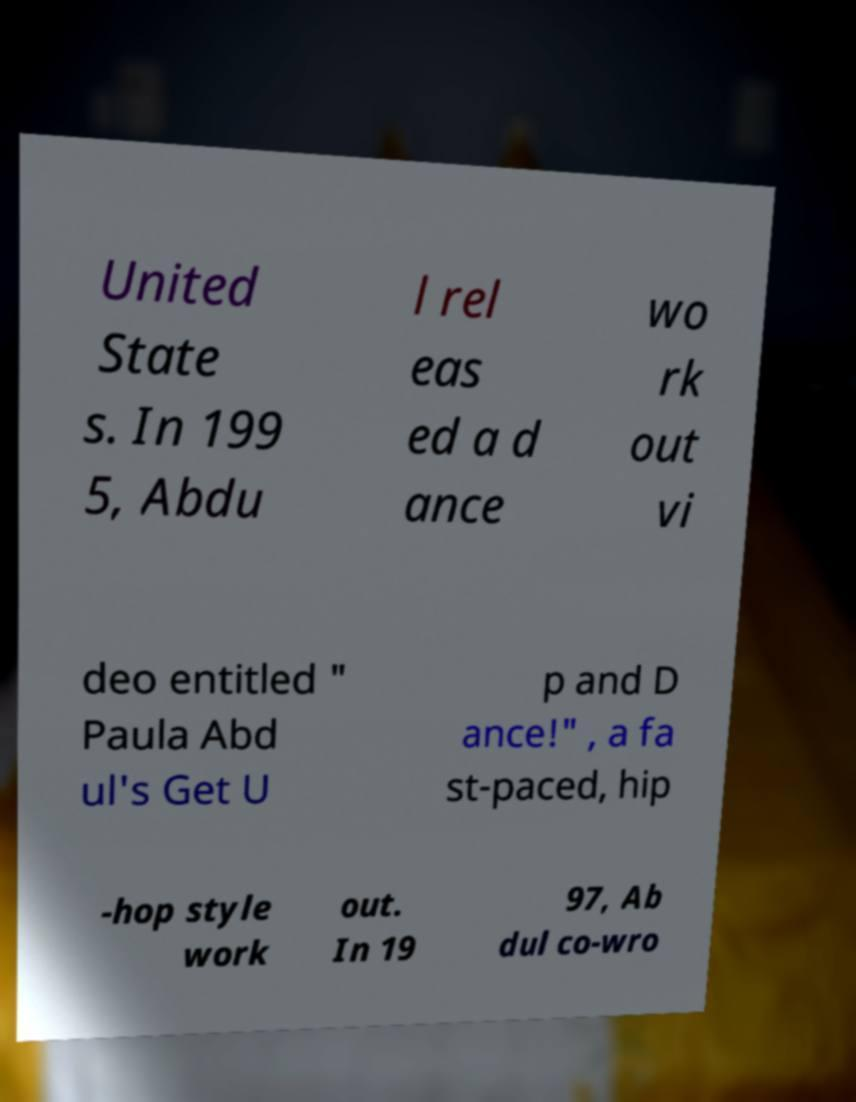Please identify and transcribe the text found in this image. United State s. In 199 5, Abdu l rel eas ed a d ance wo rk out vi deo entitled " Paula Abd ul's Get U p and D ance!" , a fa st-paced, hip -hop style work out. In 19 97, Ab dul co-wro 